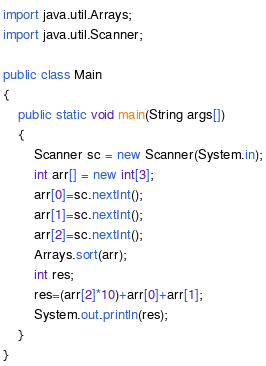<code> <loc_0><loc_0><loc_500><loc_500><_Java_>import java.util.Arrays;
import java.util.Scanner;

public class Main 
{
	public static void main(String args[])
	{
		Scanner sc = new Scanner(System.in);
		int arr[] = new int[3];
		arr[0]=sc.nextInt();
		arr[1]=sc.nextInt();
		arr[2]=sc.nextInt();
		Arrays.sort(arr);
		int res;
		res=(arr[2]*10)+arr[0]+arr[1];
		System.out.println(res);
	}
}
</code> 